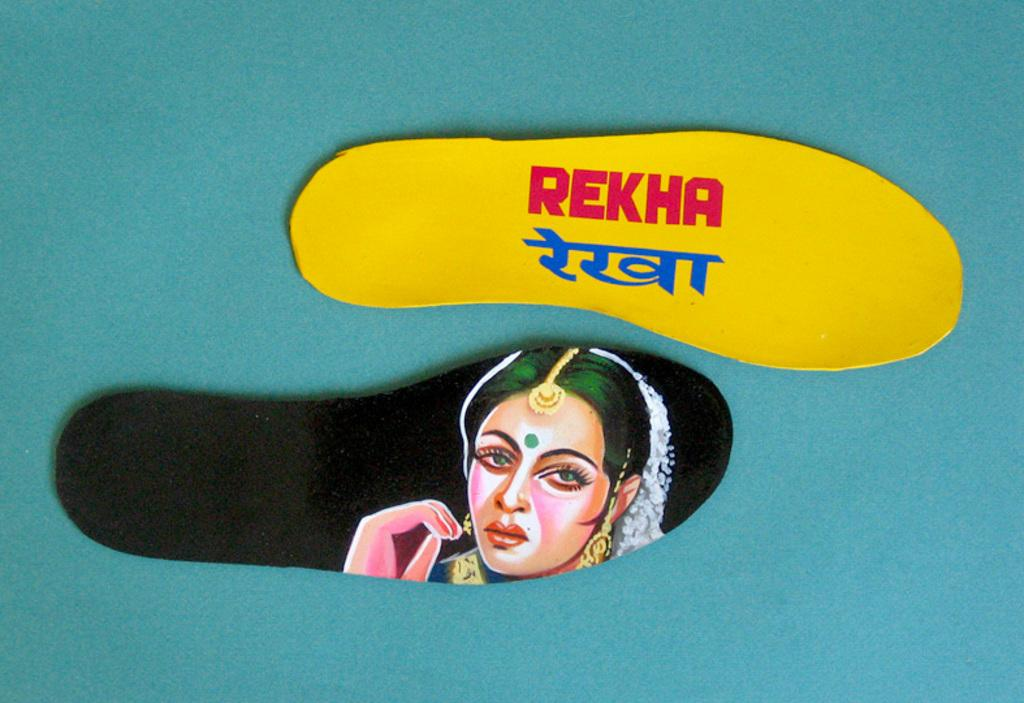What is the main subject of the image? The main subject of the image is a group of shoe soles. What can be seen on the shoe soles? There is text printed on the shoe soles. What type of organization is depicted on the shoe soles in the image? There is no organization depicted on the shoe soles in the image; it only shows text printed on them. How much sugar is present on the shoe soles in the image? There is no sugar present on the shoe soles in the image; it only shows text printed on them. 